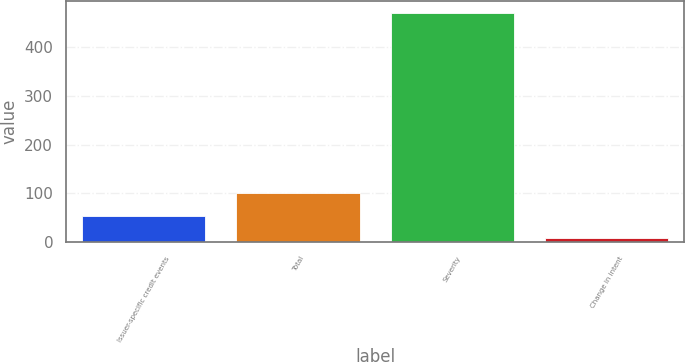Convert chart. <chart><loc_0><loc_0><loc_500><loc_500><bar_chart><fcel>Issuer-specific credit events<fcel>Total<fcel>Severity<fcel>Change in intent<nl><fcel>54.3<fcel>100.6<fcel>471<fcel>8<nl></chart> 